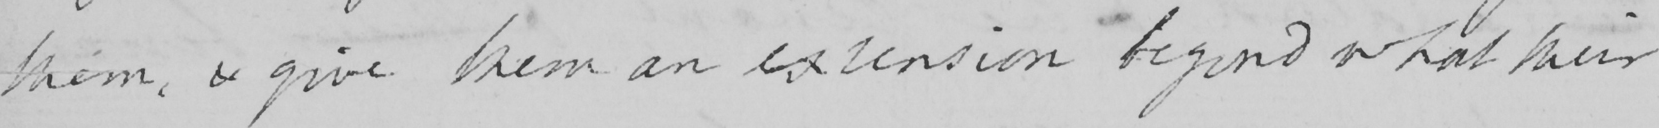Can you read and transcribe this handwriting? them , & give them an extension beyond what their 